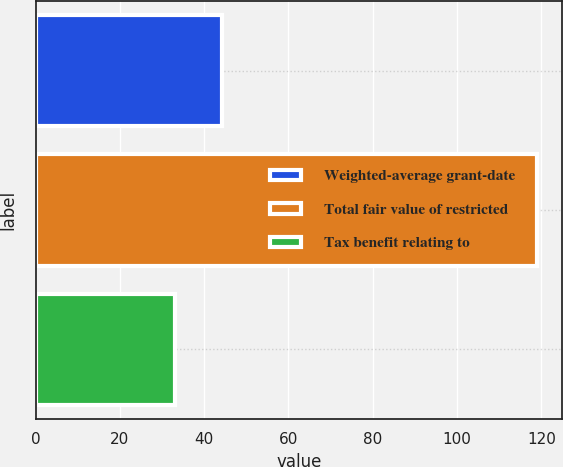Convert chart to OTSL. <chart><loc_0><loc_0><loc_500><loc_500><bar_chart><fcel>Weighted-average grant-date<fcel>Total fair value of restricted<fcel>Tax benefit relating to<nl><fcel>44.22<fcel>119<fcel>33<nl></chart> 